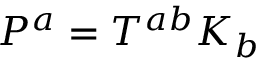Convert formula to latex. <formula><loc_0><loc_0><loc_500><loc_500>P ^ { a } = T ^ { a b } K _ { b }</formula> 